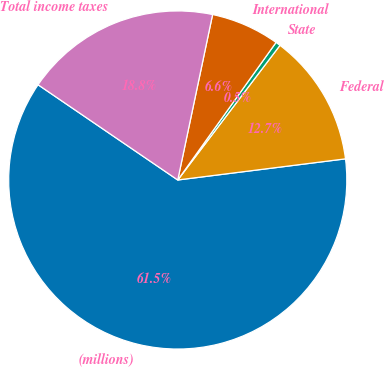<chart> <loc_0><loc_0><loc_500><loc_500><pie_chart><fcel>(millions)<fcel>Federal<fcel>State<fcel>International<fcel>Total income taxes<nl><fcel>61.52%<fcel>12.67%<fcel>0.46%<fcel>6.57%<fcel>18.78%<nl></chart> 